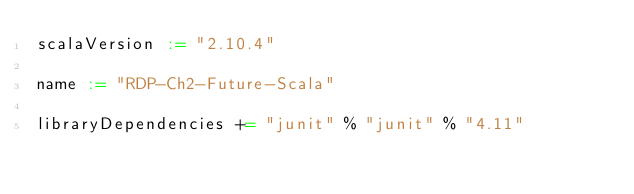<code> <loc_0><loc_0><loc_500><loc_500><_Scala_>scalaVersion := "2.10.4"

name := "RDP-Ch2-Future-Scala"

libraryDependencies += "junit" % "junit" % "4.11"
</code> 